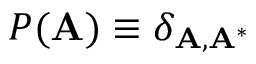Convert formula to latex. <formula><loc_0><loc_0><loc_500><loc_500>P ( A ) \equiv \delta _ { A , A ^ { * } }</formula> 